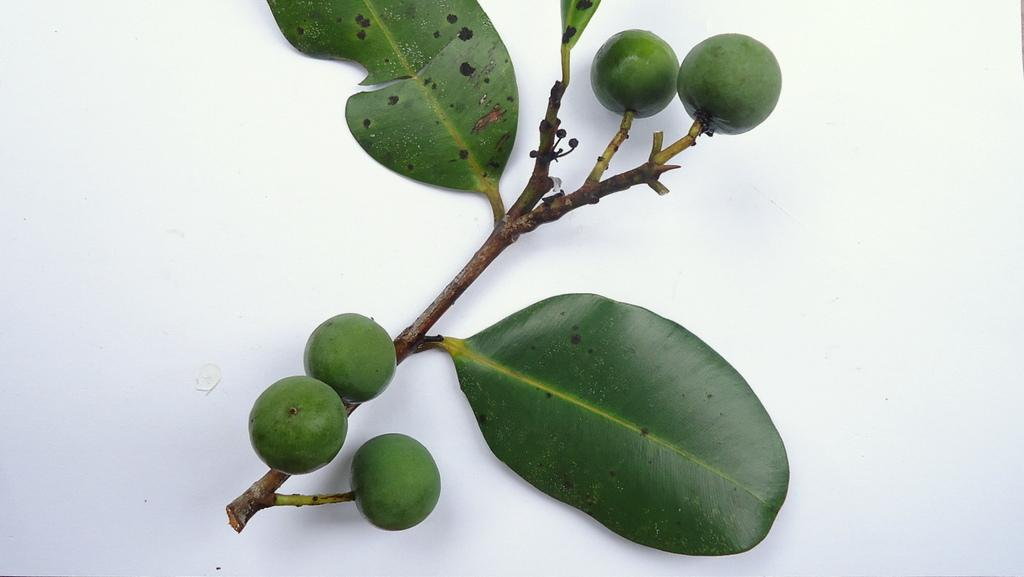What type of vegetation can be seen in the image? There are leaves in the image. What type of fruits are present in the image? There are green color fruits in the image. What is the color of the surface on which the leaves and fruits are placed? The surface on which the leaves and fruits are placed is white in color. Can you see any light reflecting off the waves in the image? There are no waves or light reflection present in the image. What type of pickle is being used to garnish the fruits in the image? There is no pickle present in the image; it features leaves and green color fruits. 